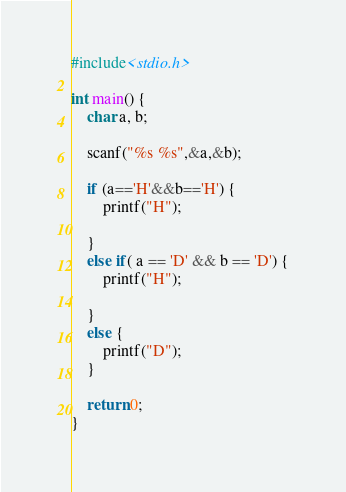<code> <loc_0><loc_0><loc_500><loc_500><_C_>#include<stdio.h>

int main() {
	char a, b;

	scanf("%s %s",&a,&b);
	
	if (a=='H'&&b=='H') {
		printf("H");

	}
	else if( a == 'D' && b == 'D') {
		printf("H");

	}
	else {
		printf("D");
	}

	return 0;
}
</code> 